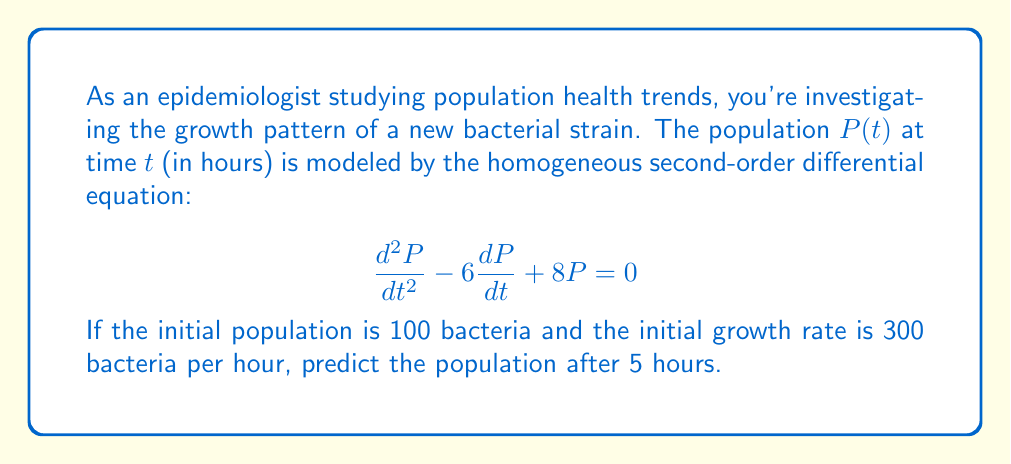Could you help me with this problem? To solve this problem, we'll follow these steps:

1) The general solution to this homogeneous second-order equation is:
   $$P(t) = C_1e^{r_1t} + C_2e^{r_2t}$$
   where $r_1$ and $r_2$ are roots of the characteristic equation.

2) The characteristic equation is:
   $$r^2 - 6r + 8 = 0$$

3) Solving this quadratic equation:
   $$r = \frac{6 \pm \sqrt{36 - 32}}{2} = \frac{6 \pm 2}{2}$$
   $$r_1 = 4, r_2 = 2$$

4) Therefore, the general solution is:
   $$P(t) = C_1e^{4t} + C_2e^{2t}$$

5) We need to find $C_1$ and $C_2$ using initial conditions:
   At $t=0$, $P(0) = 100$ and $P'(0) = 300$

6) From $P(0) = 100$:
   $$100 = C_1 + C_2$$

7) Taking the derivative of $P(t)$:
   $$P'(t) = 4C_1e^{4t} + 2C_2e^{2t}$$
   At $t=0$, $P'(0) = 300$:
   $$300 = 4C_1 + 2C_2$$

8) Solving these simultaneous equations:
   $$C_1 = 50, C_2 = 50$$

9) The particular solution is:
   $$P(t) = 50e^{4t} + 50e^{2t}$$

10) To find the population after 5 hours, we evaluate $P(5)$:
    $$P(5) = 50e^{4(5)} + 50e^{2(5)} = 50e^{20} + 50e^{10}$$
Answer: $P(5) = 50e^{20} + 50e^{10} \approx 2.98 \times 10^9$ bacteria (rounded to 3 significant figures) 